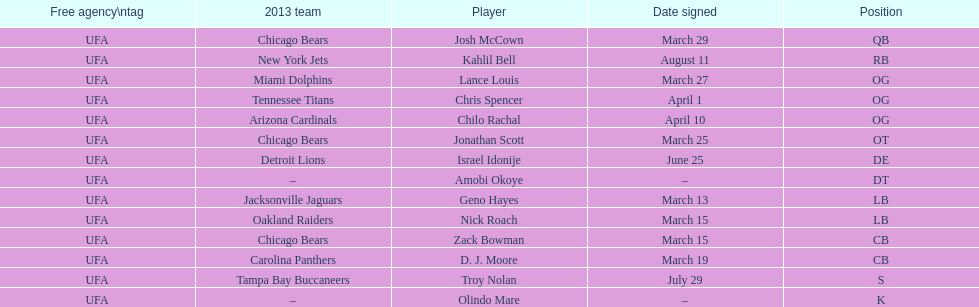Nick roach was signed the same day as what other player? Zack Bowman. I'm looking to parse the entire table for insights. Could you assist me with that? {'header': ['Free agency\\ntag', '2013 team', 'Player', 'Date signed', 'Position'], 'rows': [['UFA', 'Chicago Bears', 'Josh McCown', 'March 29', 'QB'], ['UFA', 'New York Jets', 'Kahlil Bell', 'August 11', 'RB'], ['UFA', 'Miami Dolphins', 'Lance Louis', 'March 27', 'OG'], ['UFA', 'Tennessee Titans', 'Chris Spencer', 'April 1', 'OG'], ['UFA', 'Arizona Cardinals', 'Chilo Rachal', 'April 10', 'OG'], ['UFA', 'Chicago Bears', 'Jonathan Scott', 'March 25', 'OT'], ['UFA', 'Detroit Lions', 'Israel Idonije', 'June 25', 'DE'], ['UFA', '–', 'Amobi Okoye', '–', 'DT'], ['UFA', 'Jacksonville Jaguars', 'Geno Hayes', 'March 13', 'LB'], ['UFA', 'Oakland Raiders', 'Nick Roach', 'March 15', 'LB'], ['UFA', 'Chicago Bears', 'Zack Bowman', 'March 15', 'CB'], ['UFA', 'Carolina Panthers', 'D. J. Moore', 'March 19', 'CB'], ['UFA', 'Tampa Bay Buccaneers', 'Troy Nolan', 'July 29', 'S'], ['UFA', '–', 'Olindo Mare', '–', 'K']]} 